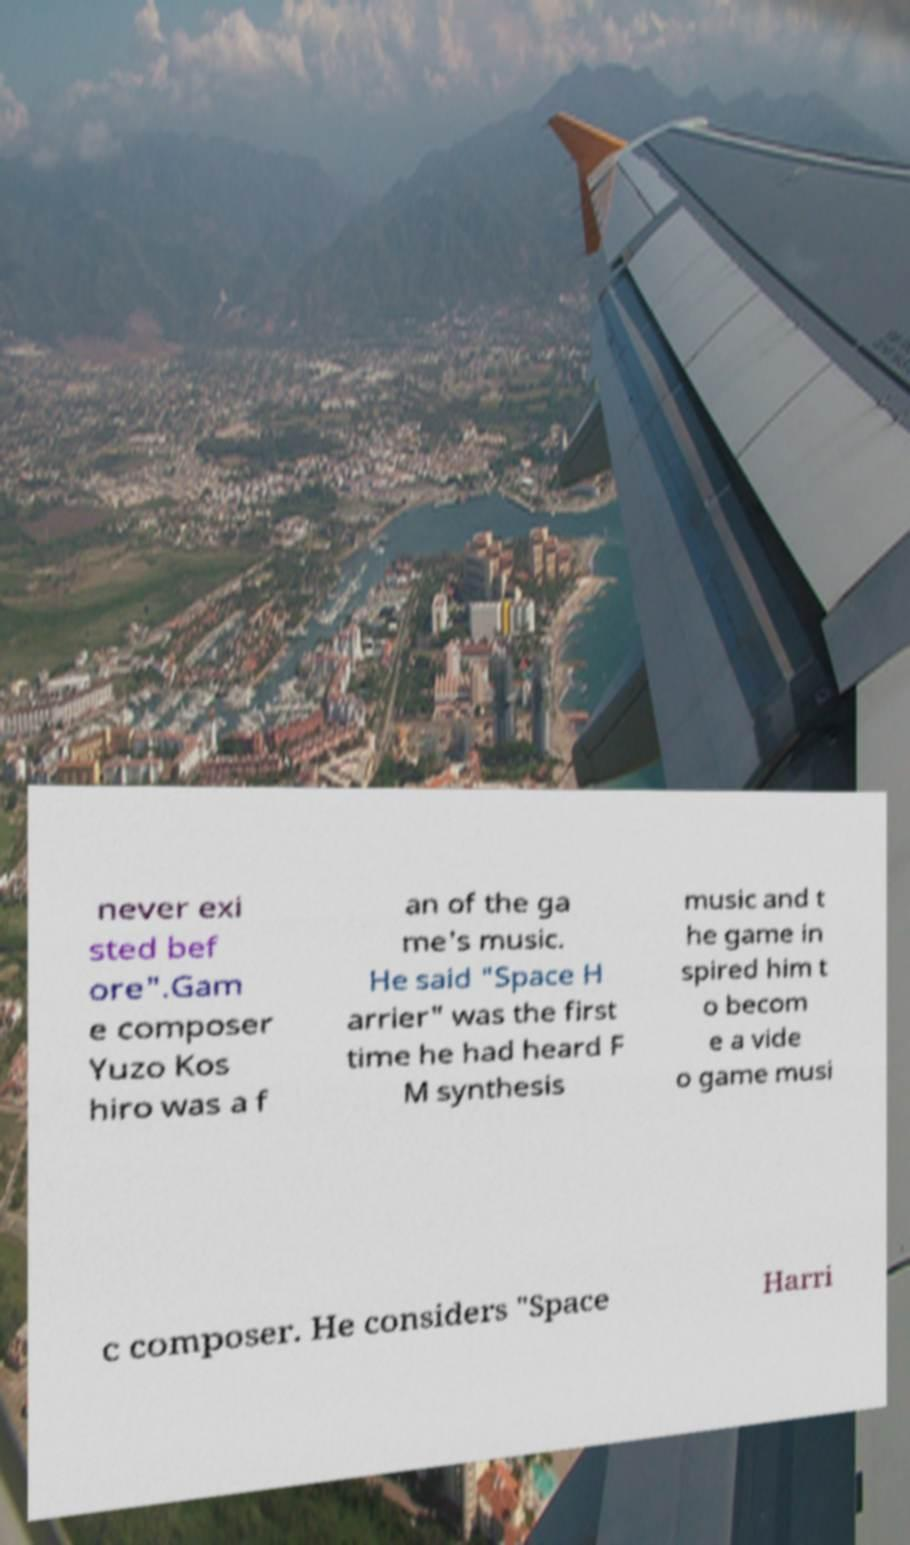Please identify and transcribe the text found in this image. never exi sted bef ore".Gam e composer Yuzo Kos hiro was a f an of the ga me's music. He said "Space H arrier" was the first time he had heard F M synthesis music and t he game in spired him t o becom e a vide o game musi c composer. He considers "Space Harri 